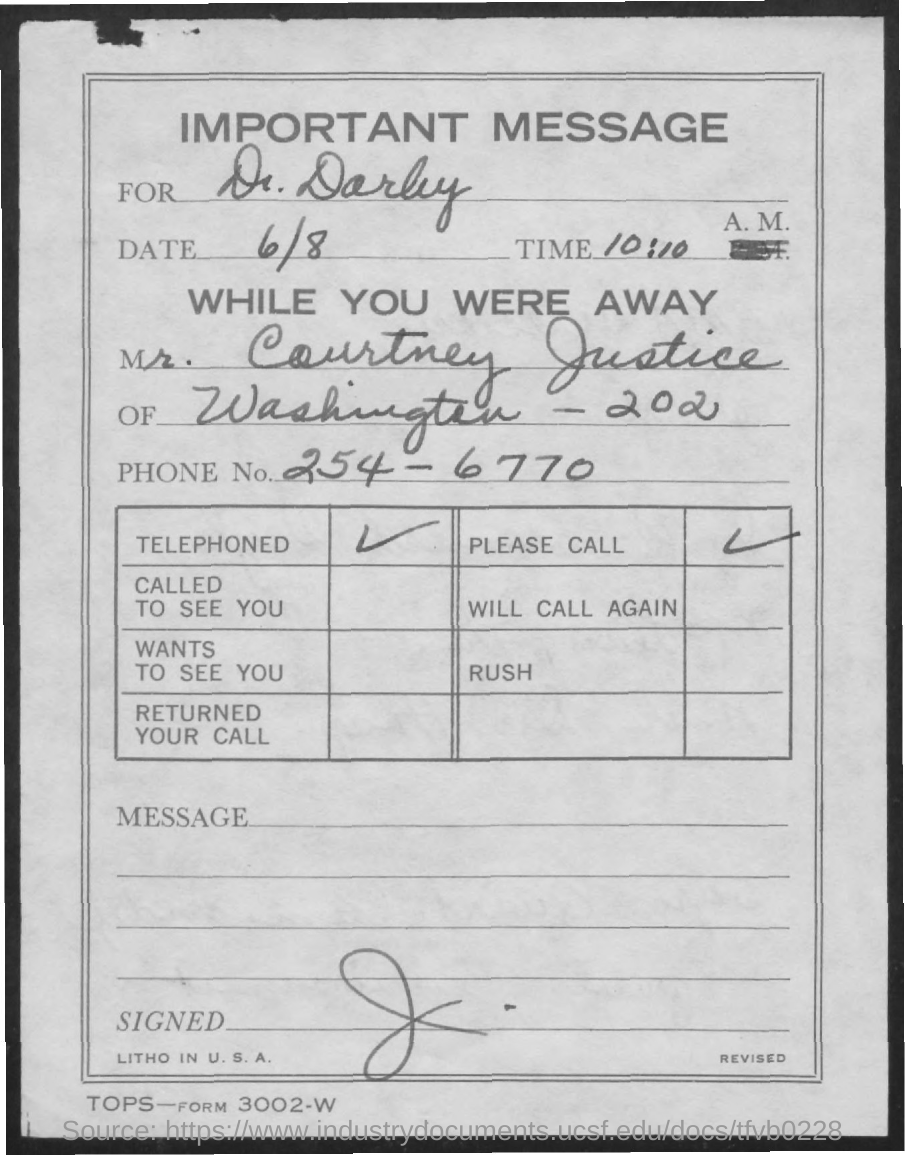Point out several critical features in this image. The message is being sent to Dr. Darby. The phone number of Mr. Courtney Justice is 254-6770. The date mentioned in this document is 6/8. 